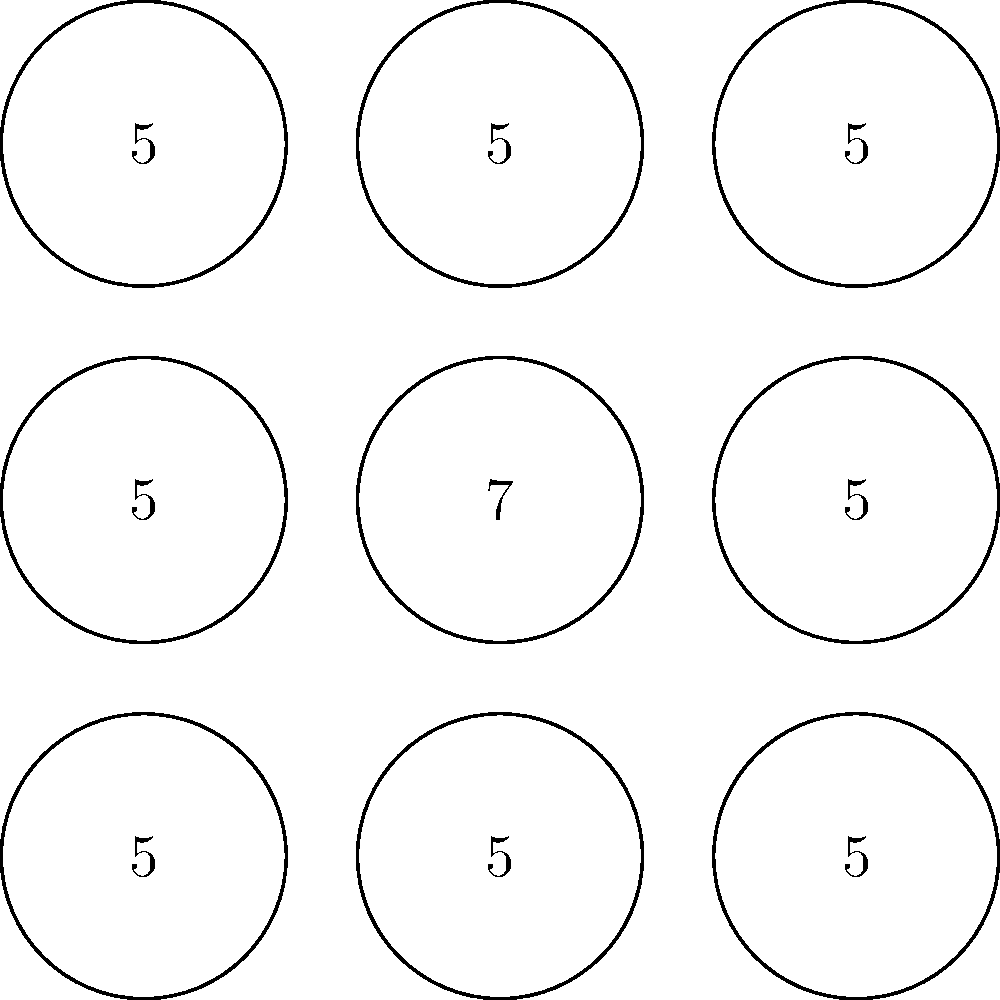In this 3x3 grid of AI-generated images, one image stands out as an anomaly. What is the value associated with the anomalous image? To identify the anomaly in this series of AI-generated images, we need to follow these steps:

1. Observe the overall pattern: The grid consists of 9 circles arranged in a 3x3 format.

2. Analyze the content of each circle: Each circle contains a number.

3. Identify the common element: Most circles contain the number 5.

4. Locate the deviation: The center circle (position (2,2) in a 1-indexed grid) contains a different number, which is 7.

5. Confirm the anomaly: All other circles contain 5, making the center circle with 7 the clear anomaly in the pattern.

6. Determine the value associated with the anomaly: The value in the anomalous circle is 7.

This type of pattern recognition is crucial in AI-based security systems, where identifying outliers or unexpected behaviors can indicate potential security threats or system malfunctions.
Answer: 7 